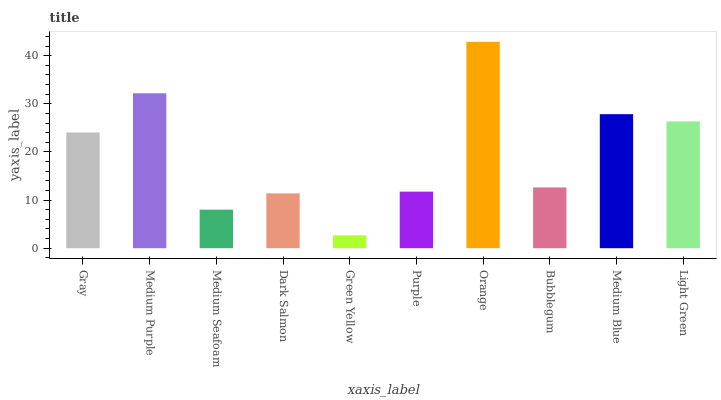Is Green Yellow the minimum?
Answer yes or no. Yes. Is Orange the maximum?
Answer yes or no. Yes. Is Medium Purple the minimum?
Answer yes or no. No. Is Medium Purple the maximum?
Answer yes or no. No. Is Medium Purple greater than Gray?
Answer yes or no. Yes. Is Gray less than Medium Purple?
Answer yes or no. Yes. Is Gray greater than Medium Purple?
Answer yes or no. No. Is Medium Purple less than Gray?
Answer yes or no. No. Is Gray the high median?
Answer yes or no. Yes. Is Bubblegum the low median?
Answer yes or no. Yes. Is Green Yellow the high median?
Answer yes or no. No. Is Medium Purple the low median?
Answer yes or no. No. 